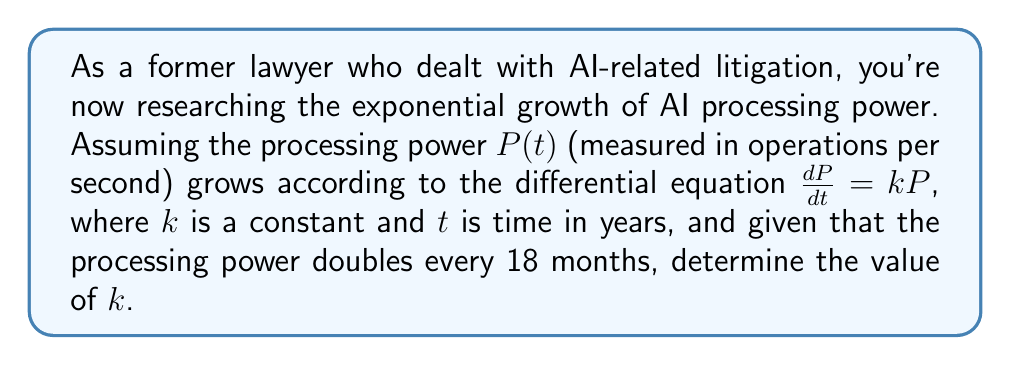Provide a solution to this math problem. 1) The given differential equation is $\frac{dP}{dt} = kP$, which describes exponential growth.

2) The general solution to this equation is:
   $$P(t) = P_0e^{kt}$$
   where $P_0$ is the initial processing power at $t=0$.

3) We're told that the processing power doubles every 18 months (1.5 years). Let's use this information:
   $$P(1.5) = 2P_0$$

4) Substituting this into our general solution:
   $$2P_0 = P_0e^{k(1.5)}$$

5) Dividing both sides by $P_0$:
   $$2 = e^{1.5k}$$

6) Taking the natural logarithm of both sides:
   $$\ln(2) = 1.5k$$

7) Solving for $k$:
   $$k = \frac{\ln(2)}{1.5} \approx 0.4621$$
Answer: $k \approx 0.4621$ year$^{-1}$ 